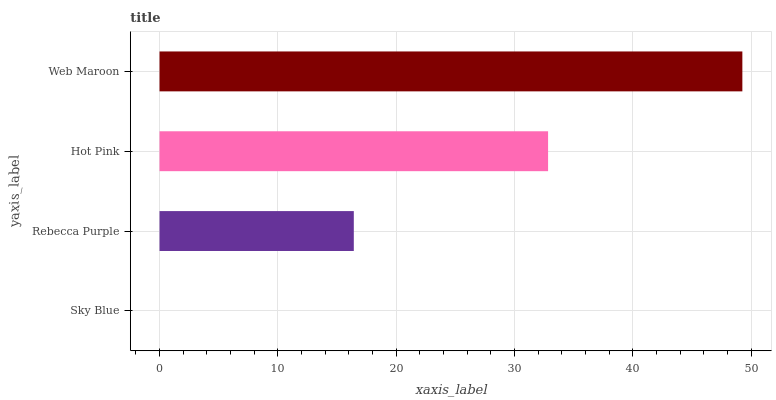Is Sky Blue the minimum?
Answer yes or no. Yes. Is Web Maroon the maximum?
Answer yes or no. Yes. Is Rebecca Purple the minimum?
Answer yes or no. No. Is Rebecca Purple the maximum?
Answer yes or no. No. Is Rebecca Purple greater than Sky Blue?
Answer yes or no. Yes. Is Sky Blue less than Rebecca Purple?
Answer yes or no. Yes. Is Sky Blue greater than Rebecca Purple?
Answer yes or no. No. Is Rebecca Purple less than Sky Blue?
Answer yes or no. No. Is Hot Pink the high median?
Answer yes or no. Yes. Is Rebecca Purple the low median?
Answer yes or no. Yes. Is Sky Blue the high median?
Answer yes or no. No. Is Sky Blue the low median?
Answer yes or no. No. 